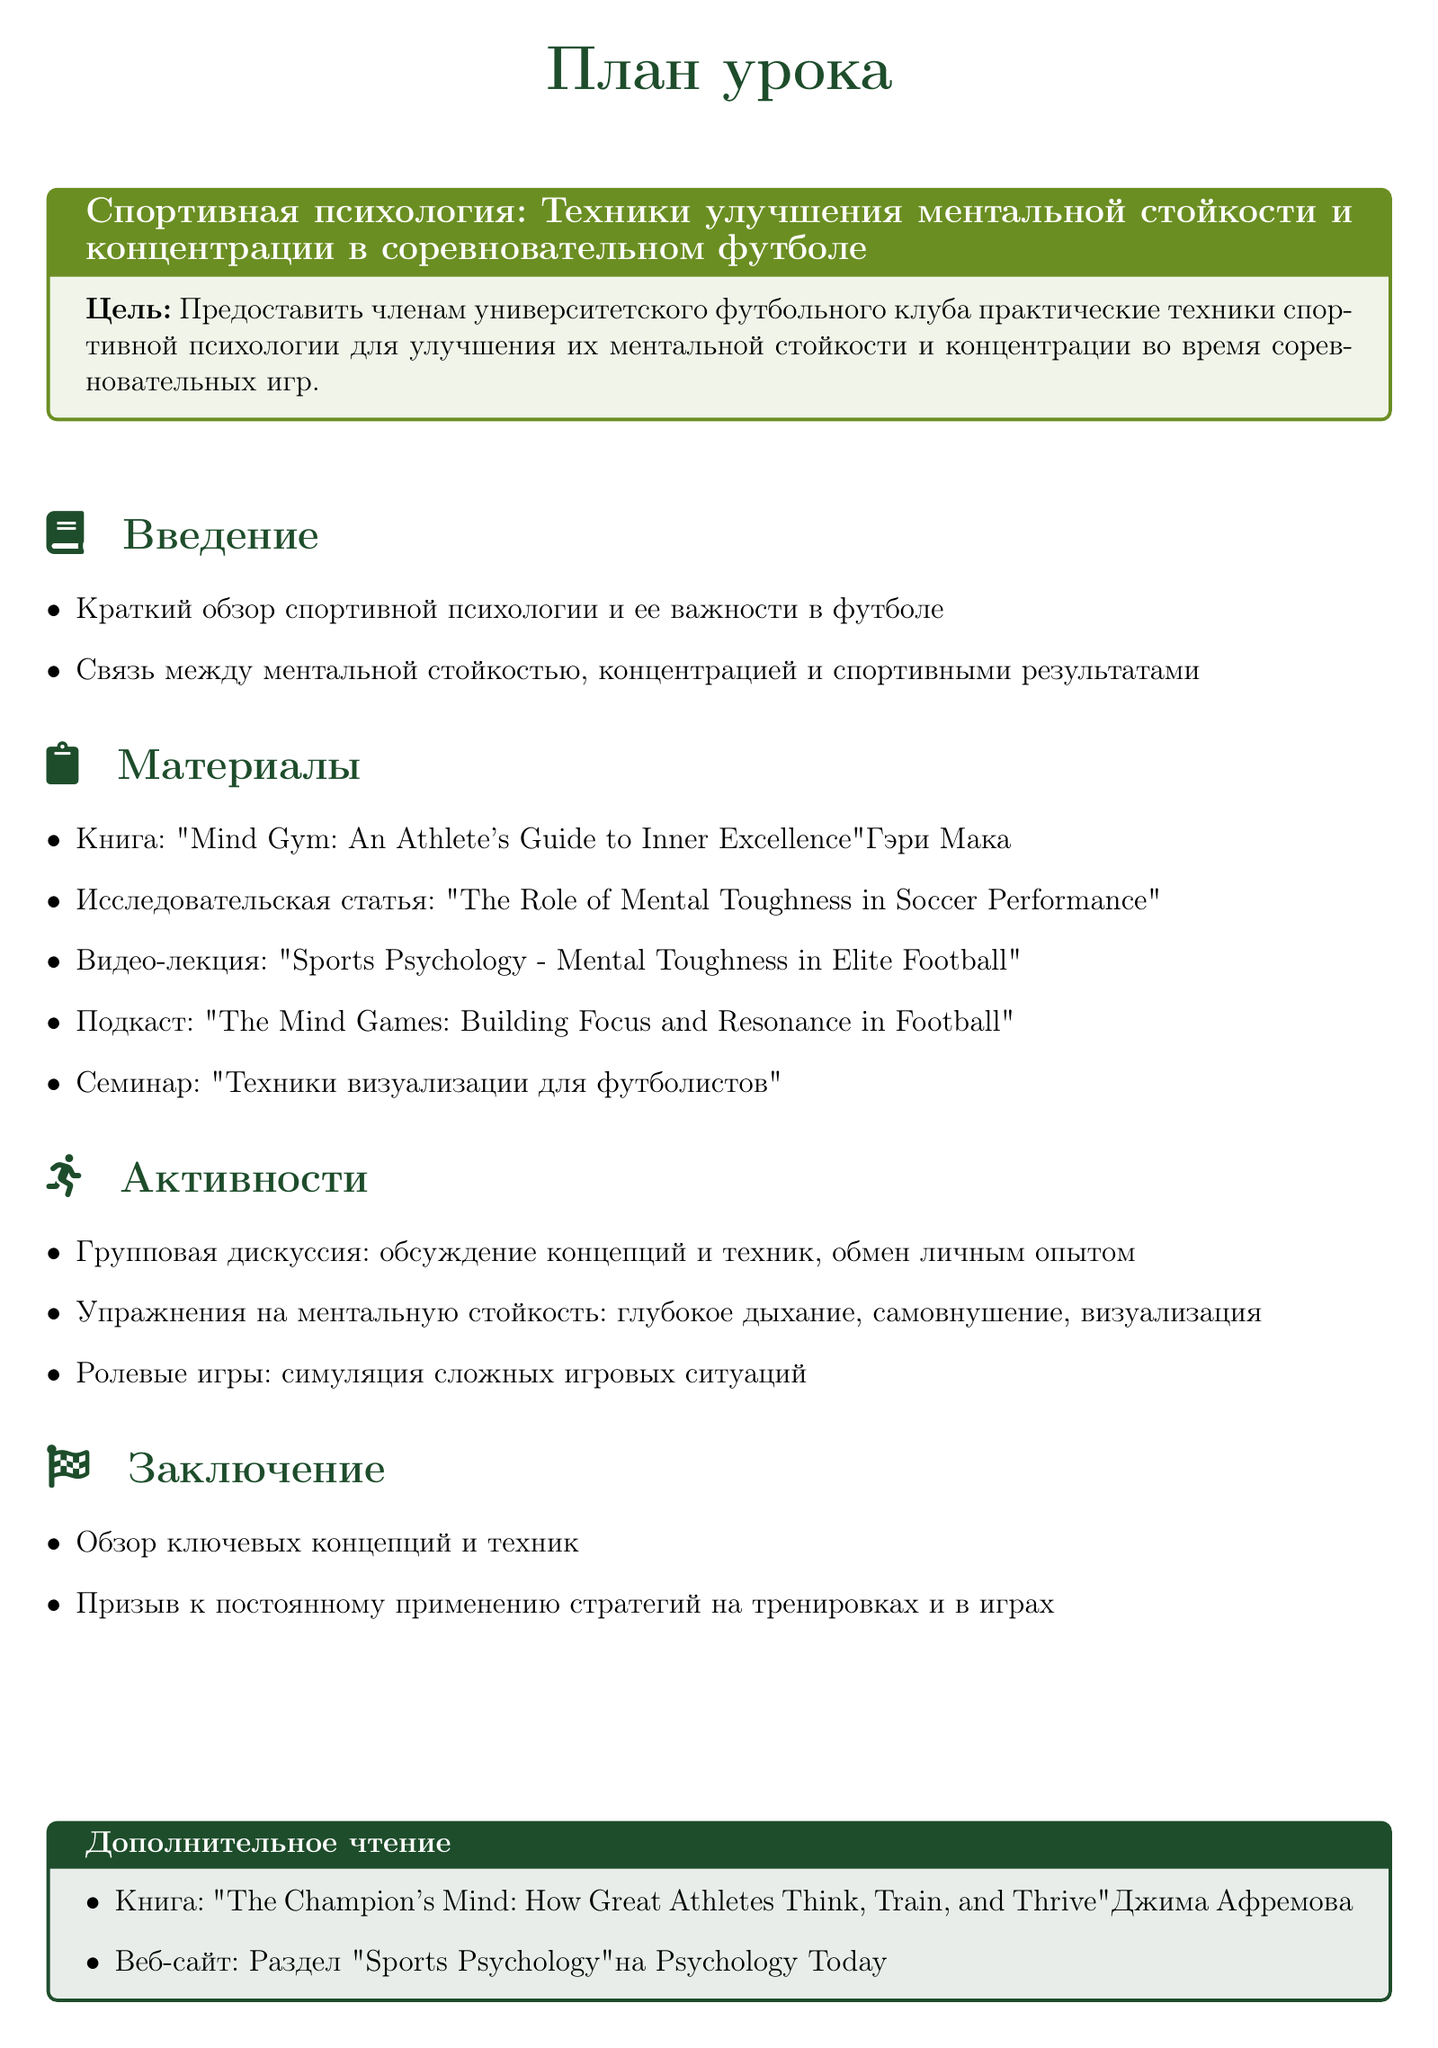Какая основная цель урока? Основная цель урока представлена в документе и включает в себя предоставление практических техник для улучшения ментальной стойкости и концентрации.
Answer: Улучшение ментальной стойкости и концентрации Какая книга рекомендована для чтения? В разделе "Материалы" упоминается книга, которая может быть полезна для студентов.
Answer: Mind Gym: An Athlete's Guide to Inner Excellence Какой тип упражнения включает в себя ролевые игры? Ролевые игры являются частью активности, где имеются симуляции сложных игровых ситуаций, что углубляет понимание студентов.
Answer: Симуляция сложных игровых ситуаций Какое количество активностей описано в документе? В разделе "Активности" перечислены три техники, что дает общее представление о количестве методов.
Answer: Три Какое видео-лекция представлена в плане урока? В разделе "Материалы" упоминается видеоресурс, который касается психологии спорта.
Answer: Sports Psychology - Mental Toughness in Elite Football Что представляет собой последний раздел документа? Последний раздел подводит итоги и подчеркивает важность применения техник на практике.
Answer: Заключение Какой семинар упомянут в плане урока? В списке материалов планируется семинар по конкретной технике в контексте футбольной подготовки.
Answer: Техники визуализации для футболистов Какой веб-сайт предлагается для дополнительного чтения? В конце документа упоминается ресурс, где можно найти дополнительную информацию по спортивной психологии.
Answer: Раздел "Sports Psychology" на Psychology Today 